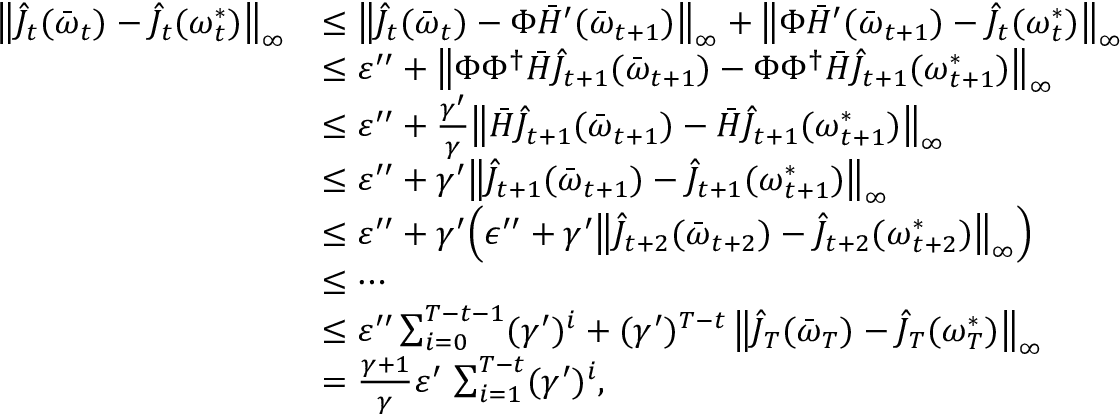<formula> <loc_0><loc_0><loc_500><loc_500>\begin{array} { r l } { \left \| \hat { J } _ { t } ( \bar { \omega } _ { t } ) - \hat { J } _ { t } ( \omega _ { t } ^ { * } ) \right \| _ { \infty } } & { \leq \left \| \hat { J } _ { t } ( \bar { \omega } _ { t } ) - \Phi \bar { H } ^ { \prime } ( \bar { \omega } _ { t + 1 } ) \right \| _ { \infty } + \left \| \Phi \bar { H } ^ { \prime } ( \bar { \omega } _ { t + 1 } ) - \hat { J } _ { t } ( \omega _ { t } ^ { * } ) \right \| _ { \infty } } \\ & { \leq \varepsilon ^ { \prime \prime } + \left \| \Phi \Phi ^ { \dagger } \bar { H } \hat { J } _ { t + 1 } ( \bar { \omega } _ { t + 1 } ) - \Phi \Phi ^ { \dagger } \bar { H } \hat { J } _ { t + 1 } ( \omega _ { t + 1 } ^ { * } ) \right \| _ { \infty } } \\ & { \leq \varepsilon ^ { \prime \prime } + \frac { \gamma ^ { \prime } } { \gamma } \left \| \bar { H } \hat { J } _ { t + 1 } ( \bar { \omega } _ { t + 1 } ) - \bar { H } \hat { J } _ { t + 1 } ( \omega _ { t + 1 } ^ { * } ) \right \| _ { \infty } } \\ & { \leq \varepsilon ^ { \prime \prime } + \gamma ^ { \prime } \left \| \hat { J } _ { t + 1 } ( \bar { \omega } _ { t + 1 } ) - \hat { J } _ { t + 1 } ( \omega _ { t + 1 } ^ { * } ) \right \| _ { \infty } } \\ & { \leq \varepsilon ^ { \prime \prime } + \gamma ^ { \prime } \left ( \epsilon ^ { \prime \prime } + \gamma ^ { \prime } \left \| \hat { J } _ { t + 2 } ( \bar { \omega } _ { t + 2 } ) - \hat { J } _ { t + 2 } ( \omega _ { t + 2 } ^ { * } ) \right \| _ { \infty } \right ) } \\ & { \leq \cdots } \\ & { \leq \varepsilon ^ { \prime \prime } \sum _ { i = 0 } ^ { T - t - 1 } ( \gamma ^ { \prime } ) ^ { i } + ( \gamma ^ { \prime } ) ^ { T - t } \, \left \| \hat { J } _ { T } ( \bar { \omega } _ { T } ) - \hat { J } _ { T } ( \omega _ { T } ^ { * } ) \right \| _ { \infty } } \\ & { = \frac { \gamma + 1 } { \gamma } \varepsilon ^ { \prime } \, \sum _ { i = 1 } ^ { T - t } ( \gamma ^ { \prime } ) ^ { i } , } \end{array}</formula> 